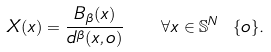Convert formula to latex. <formula><loc_0><loc_0><loc_500><loc_500>X ( x ) = \frac { B _ { \beta } ( x ) } { d ^ { \beta } ( x , o ) } \quad \forall x \in \mathbb { S } ^ { N } \ \{ o \} .</formula> 